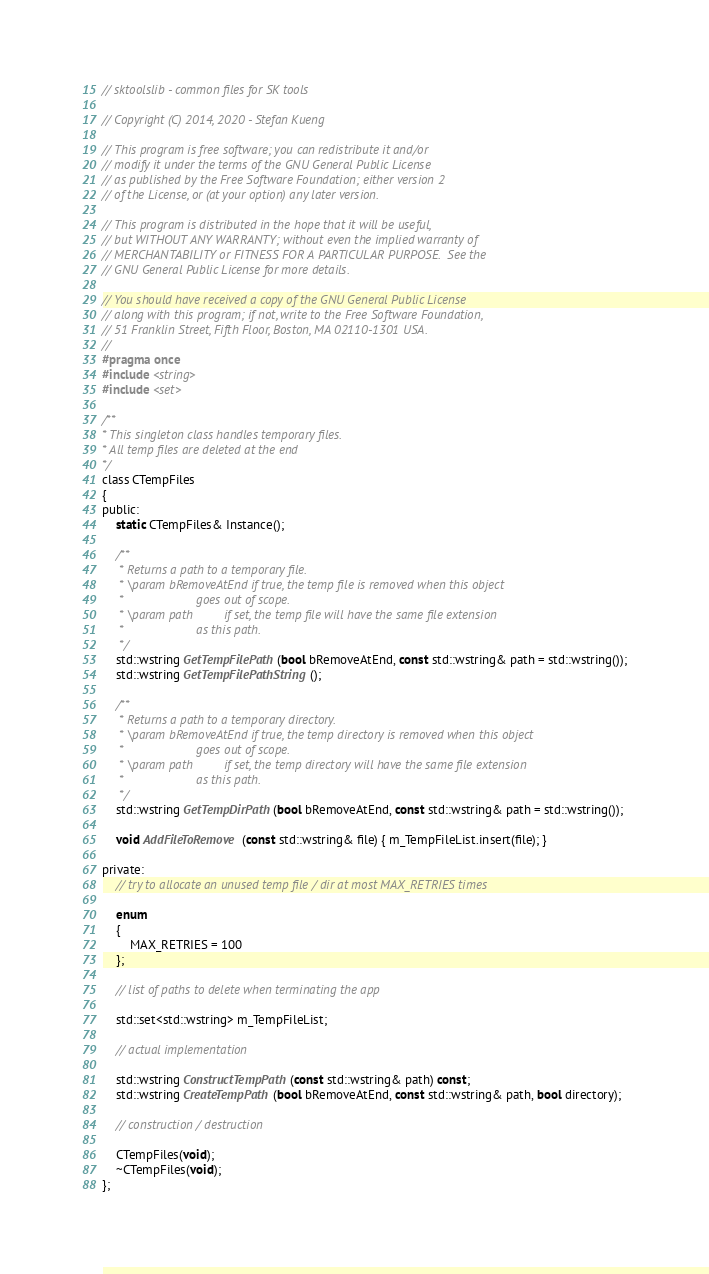Convert code to text. <code><loc_0><loc_0><loc_500><loc_500><_C_>// sktoolslib - common files for SK tools

// Copyright (C) 2014, 2020 - Stefan Kueng

// This program is free software; you can redistribute it and/or
// modify it under the terms of the GNU General Public License
// as published by the Free Software Foundation; either version 2
// of the License, or (at your option) any later version.

// This program is distributed in the hope that it will be useful,
// but WITHOUT ANY WARRANTY; without even the implied warranty of
// MERCHANTABILITY or FITNESS FOR A PARTICULAR PURPOSE.  See the
// GNU General Public License for more details.

// You should have received a copy of the GNU General Public License
// along with this program; if not, write to the Free Software Foundation,
// 51 Franklin Street, Fifth Floor, Boston, MA 02110-1301 USA.
//
#pragma once
#include <string>
#include <set>

/**
* This singleton class handles temporary files.
* All temp files are deleted at the end
*/
class CTempFiles
{
public:
    static CTempFiles& Instance();

    /**
     * Returns a path to a temporary file.
     * \param bRemoveAtEnd if true, the temp file is removed when this object
     *                     goes out of scope.
     * \param path         if set, the temp file will have the same file extension
     *                     as this path.
     */
    std::wstring GetTempFilePath(bool bRemoveAtEnd, const std::wstring& path = std::wstring());
    std::wstring GetTempFilePathString();

    /**
     * Returns a path to a temporary directory.
     * \param bRemoveAtEnd if true, the temp directory is removed when this object
     *                     goes out of scope.
     * \param path         if set, the temp directory will have the same file extension
     *                     as this path.
     */
    std::wstring GetTempDirPath(bool bRemoveAtEnd, const std::wstring& path = std::wstring());

    void AddFileToRemove(const std::wstring& file) { m_TempFileList.insert(file); }

private:
    // try to allocate an unused temp file / dir at most MAX_RETRIES times

    enum
    {
        MAX_RETRIES = 100
    };

    // list of paths to delete when terminating the app

    std::set<std::wstring> m_TempFileList;

    // actual implementation

    std::wstring ConstructTempPath(const std::wstring& path) const;
    std::wstring CreateTempPath(bool bRemoveAtEnd, const std::wstring& path, bool directory);

    // construction / destruction

    CTempFiles(void);
    ~CTempFiles(void);
};
</code> 